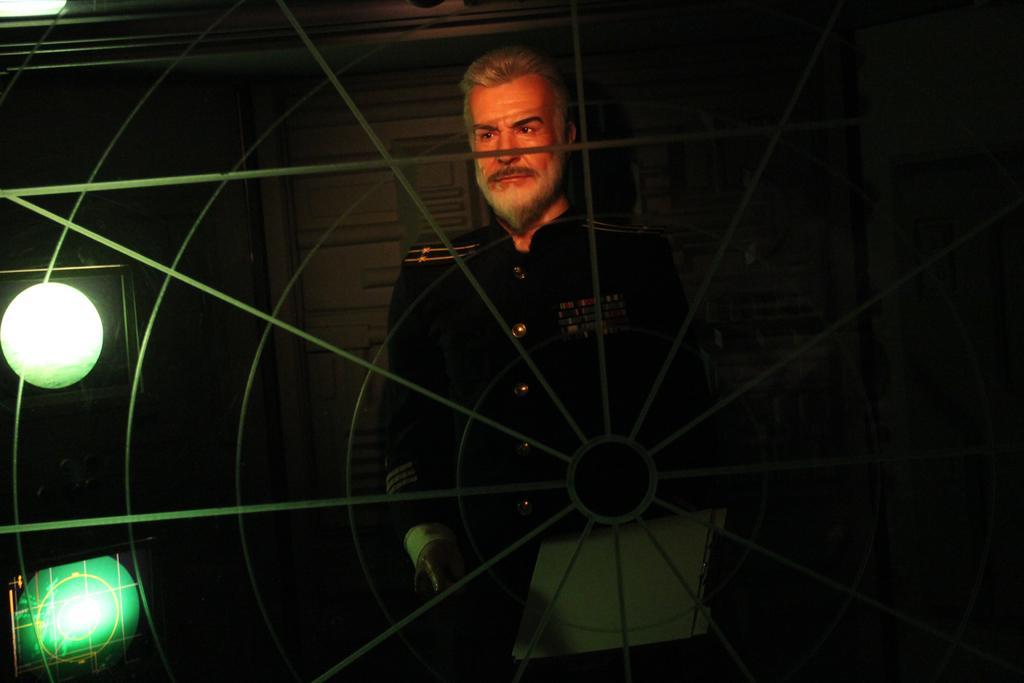Can you describe this image briefly? In this image, we can see wheel. Through the wheel we can see a person standing. In the background, we can see the wall, lights, some objects and dark view. 